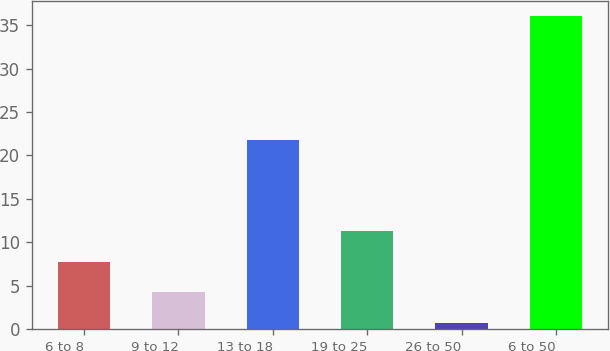Convert chart to OTSL. <chart><loc_0><loc_0><loc_500><loc_500><bar_chart><fcel>6 to 8<fcel>9 to 12<fcel>13 to 18<fcel>19 to 25<fcel>26 to 50<fcel>6 to 50<nl><fcel>7.76<fcel>4.23<fcel>21.8<fcel>11.29<fcel>0.7<fcel>36<nl></chart> 